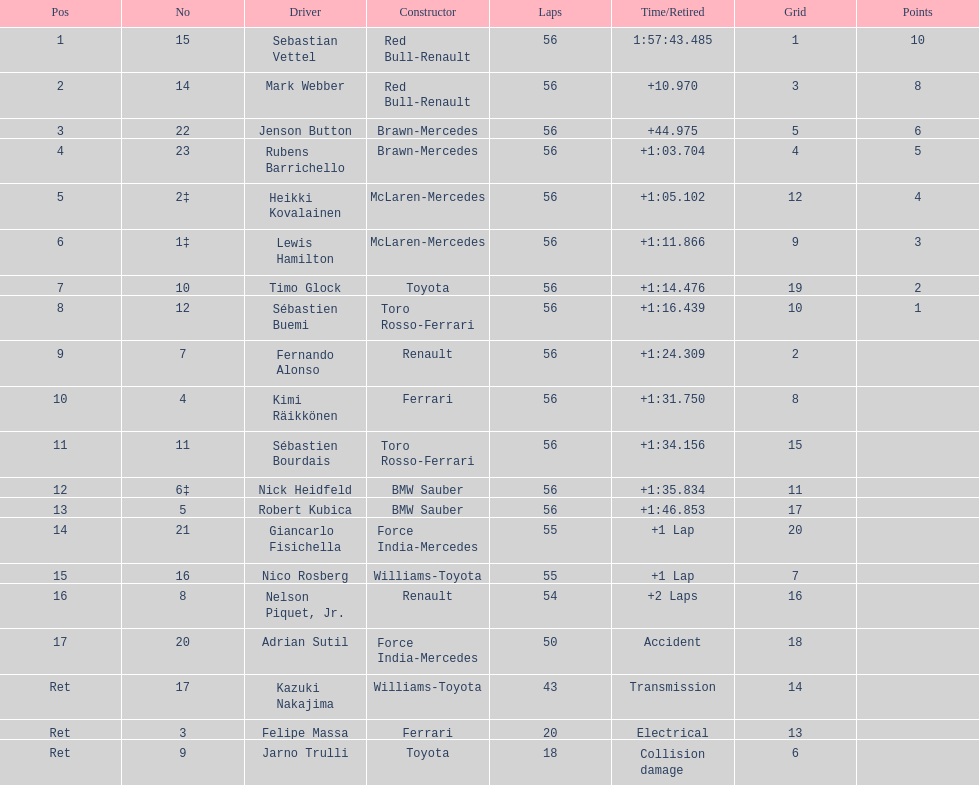Can you provide a list of the drivers? Sebastian Vettel, Mark Webber, Jenson Button, Rubens Barrichello, Heikki Kovalainen, Lewis Hamilton, Timo Glock, Sébastien Buemi, Fernando Alonso, Kimi Räikkönen, Sébastien Bourdais, Nick Heidfeld, Robert Kubica, Giancarlo Fisichella, Nico Rosberg, Nelson Piquet, Jr., Adrian Sutil, Kazuki Nakajima, Felipe Massa, Jarno Trulli. What were their completion times? 1:57:43.485, +10.970, +44.975, +1:03.704, +1:05.102, +1:11.866, +1:14.476, +1:16.439, +1:24.309, +1:31.750, +1:34.156, +1:35.834, +1:46.853, +1 Lap, +1 Lap, +2 Laps, Accident, Transmission, Electrical, Collision damage. Which driver finished last? Robert Kubica. 